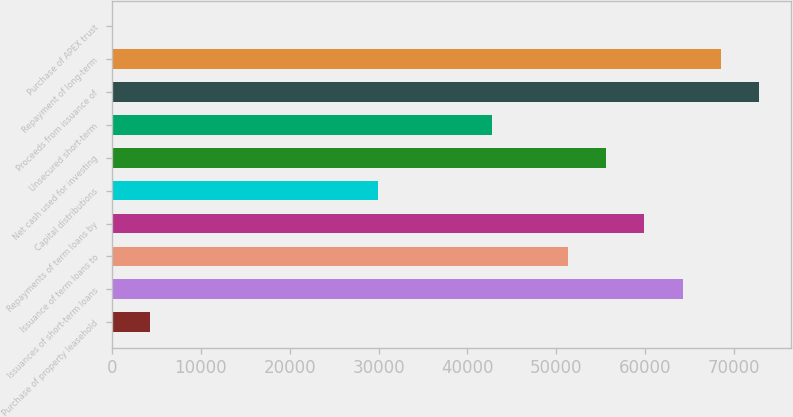<chart> <loc_0><loc_0><loc_500><loc_500><bar_chart><fcel>Purchase of property leasehold<fcel>Issuances of short-term loans<fcel>Issuance of term loans to<fcel>Repayments of term loans by<fcel>Capital distributions<fcel>Net cash used for investing<fcel>Unsecured short-term<fcel>Proceeds from issuance of<fcel>Repayment of long-term<fcel>Purchase of APEX trust<nl><fcel>4280.4<fcel>64192<fcel>51353.8<fcel>59912.6<fcel>29956.8<fcel>55633.2<fcel>42795<fcel>72750.8<fcel>68471.4<fcel>1<nl></chart> 